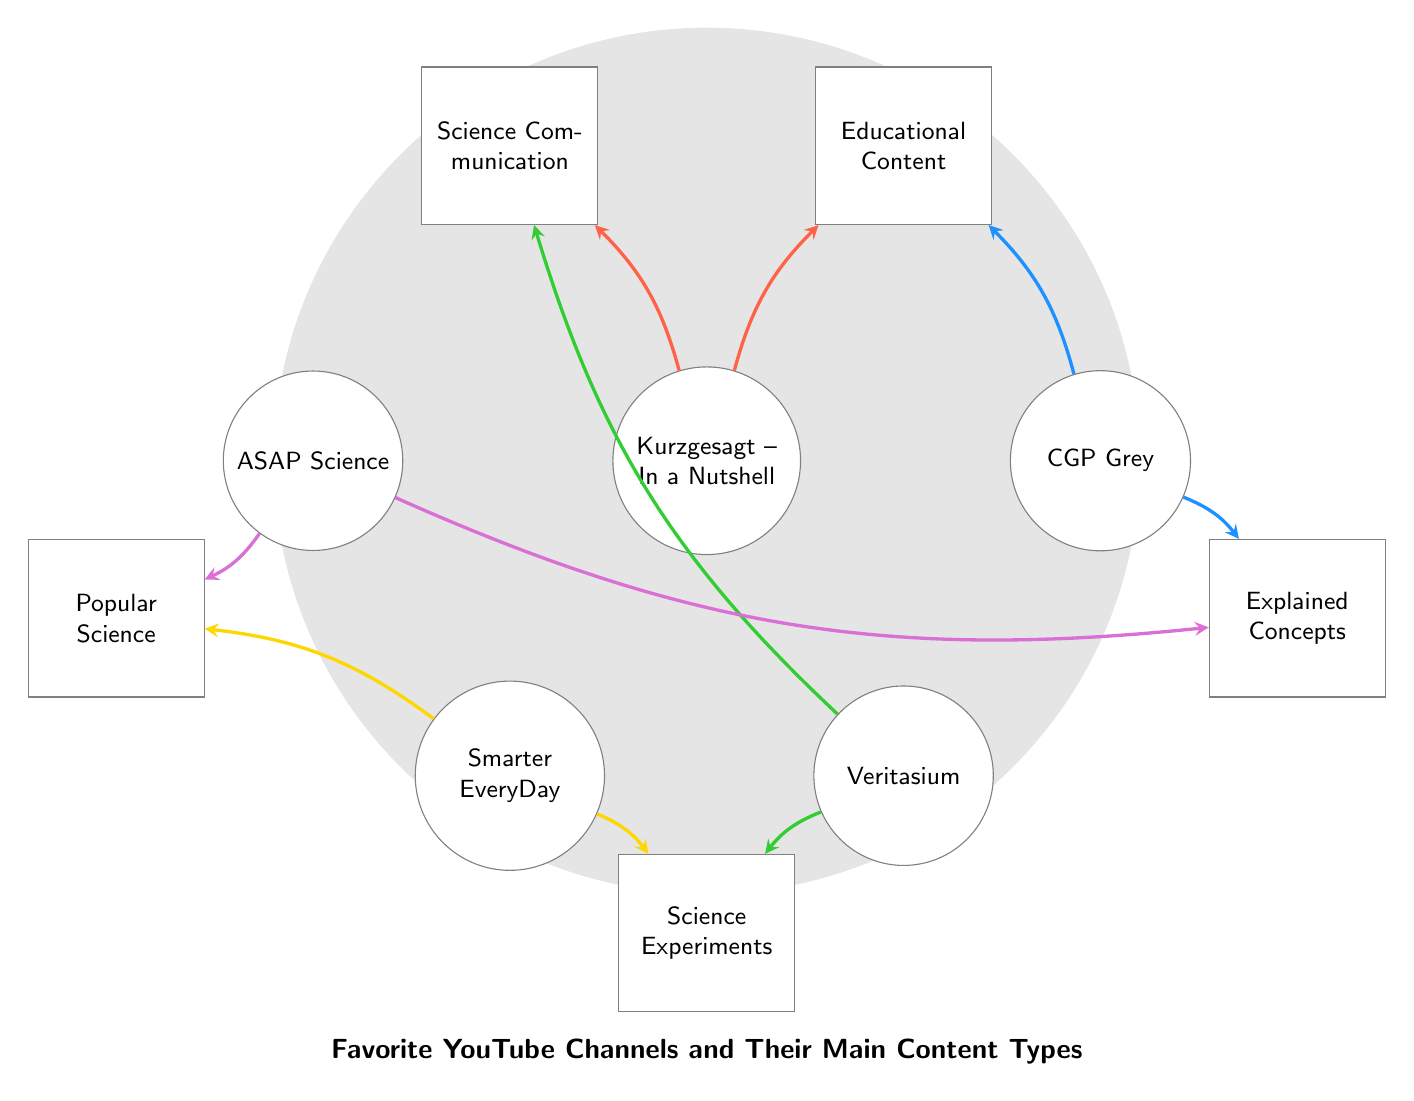What is the total number of channels in the diagram? The diagram includes five distinct channels: Kurzgesagt – In a Nutshell, CGP Grey, Veritasium, SmarterEveryDay, and ASAPScience. By simply counting these nodes, we find there are 5 channels.
Answer: 5 Which content type is connected to the most channels? By looking at the connections, "Popular Science" is connected to the channels SmarterEveryDay and ASAPScience, indicating 2 connections. Other content types like "Science Communication" and "Explained Concepts" are connected to 2 channels each as well. However, "Science Experiments" is only connected to 2 channels too. Thus, all three content types share the highest connectivity.
Answer: Popular Science, Science Communication, Explained Concepts What does Kurzgesagt – In a Nutshell focus on besides educational content? The diagram shows that Kurzgesagt – In a Nutshell connects to both "Educational Content" and "Science Communication". The additional connection indicates a second focus area.
Answer: Science Communication How many different content types are represented in total? Counting the unique content nodes: Educational Content, Science Communication, Explained Concepts, Science Experiments, and Popular Science gives a total of 5 distinct content types represented in this diagram.
Answer: 5 Which YouTube channel focuses on explaining concepts? The diagram shows that CGP Grey connects to "Explained Concepts" directly. Since it is the only channel linked to this specific content type, it clearly indicates CGP Grey's focus.
Answer: CGP Grey Which pair of channels shares a common content type? By observing the connections, we see that both SmarterEveryDay and ASAPScience share the content type "Popular Science", forming a clear link between the two channels based on their content focus.
Answer: SmarterEveryDay and ASAPScience How many connections does Veritasium have? Veritasium is linked to two content types: "Science Communication" and "Science Experiments". This means it has a total of 2 outgoing connections in the diagram.
Answer: 2 Which content type is specifically linked to science experiments? The diagram indicates that "Science Experiments" is directly connected to two channels: Veritasium and SmarterEveryDay. This pinpoints which content types are dedicated to science experiments.
Answer: Science Experiments Which YouTube channel is not connected to educational content? By reviewing the connections, we see that SmarterEveryDay and ASAPScience do not have a direct link to "Educational Content", indicating their unrealized involvement in this area.
Answer: SmarterEveryDay and ASAPScience 